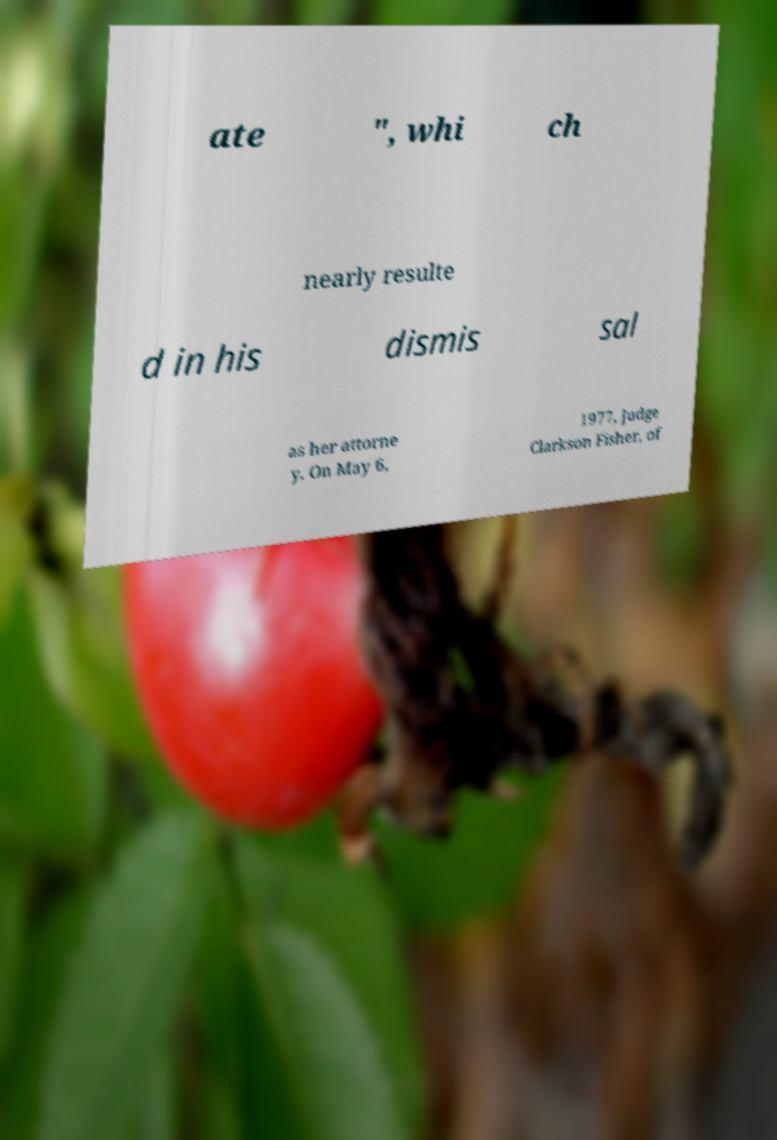For documentation purposes, I need the text within this image transcribed. Could you provide that? ate ", whi ch nearly resulte d in his dismis sal as her attorne y. On May 6, 1977, Judge Clarkson Fisher, of 